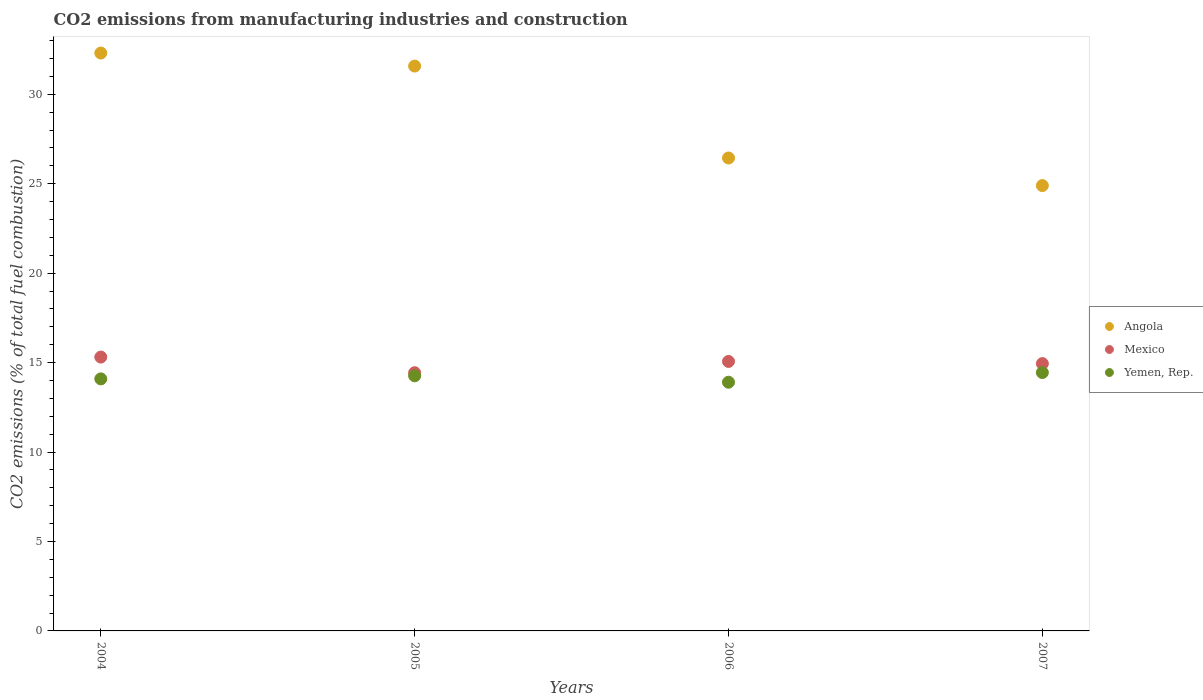Is the number of dotlines equal to the number of legend labels?
Keep it short and to the point. Yes. What is the amount of CO2 emitted in Yemen, Rep. in 2005?
Provide a short and direct response. 14.26. Across all years, what is the maximum amount of CO2 emitted in Yemen, Rep.?
Provide a succinct answer. 14.44. Across all years, what is the minimum amount of CO2 emitted in Yemen, Rep.?
Keep it short and to the point. 13.9. What is the total amount of CO2 emitted in Angola in the graph?
Your answer should be compact. 115.22. What is the difference between the amount of CO2 emitted in Angola in 2004 and that in 2007?
Provide a short and direct response. 7.41. What is the difference between the amount of CO2 emitted in Mexico in 2006 and the amount of CO2 emitted in Yemen, Rep. in 2004?
Keep it short and to the point. 0.97. What is the average amount of CO2 emitted in Mexico per year?
Your response must be concise. 14.94. In the year 2005, what is the difference between the amount of CO2 emitted in Angola and amount of CO2 emitted in Yemen, Rep.?
Give a very brief answer. 17.32. What is the ratio of the amount of CO2 emitted in Mexico in 2004 to that in 2006?
Provide a succinct answer. 1.02. Is the difference between the amount of CO2 emitted in Angola in 2005 and 2006 greater than the difference between the amount of CO2 emitted in Yemen, Rep. in 2005 and 2006?
Provide a short and direct response. Yes. What is the difference between the highest and the second highest amount of CO2 emitted in Mexico?
Provide a short and direct response. 0.24. What is the difference between the highest and the lowest amount of CO2 emitted in Angola?
Provide a succinct answer. 7.41. In how many years, is the amount of CO2 emitted in Mexico greater than the average amount of CO2 emitted in Mexico taken over all years?
Give a very brief answer. 3. Is the sum of the amount of CO2 emitted in Yemen, Rep. in 2006 and 2007 greater than the maximum amount of CO2 emitted in Mexico across all years?
Offer a terse response. Yes. Does the amount of CO2 emitted in Mexico monotonically increase over the years?
Your answer should be very brief. No. Is the amount of CO2 emitted in Mexico strictly less than the amount of CO2 emitted in Yemen, Rep. over the years?
Offer a very short reply. No. How many years are there in the graph?
Ensure brevity in your answer.  4. How are the legend labels stacked?
Give a very brief answer. Vertical. What is the title of the graph?
Provide a short and direct response. CO2 emissions from manufacturing industries and construction. What is the label or title of the Y-axis?
Your response must be concise. CO2 emissions (% of total fuel combustion). What is the CO2 emissions (% of total fuel combustion) of Angola in 2004?
Ensure brevity in your answer.  32.31. What is the CO2 emissions (% of total fuel combustion) in Mexico in 2004?
Your response must be concise. 15.31. What is the CO2 emissions (% of total fuel combustion) in Yemen, Rep. in 2004?
Your response must be concise. 14.09. What is the CO2 emissions (% of total fuel combustion) in Angola in 2005?
Keep it short and to the point. 31.58. What is the CO2 emissions (% of total fuel combustion) of Mexico in 2005?
Offer a terse response. 14.44. What is the CO2 emissions (% of total fuel combustion) of Yemen, Rep. in 2005?
Provide a short and direct response. 14.26. What is the CO2 emissions (% of total fuel combustion) in Angola in 2006?
Offer a very short reply. 26.44. What is the CO2 emissions (% of total fuel combustion) of Mexico in 2006?
Provide a short and direct response. 15.07. What is the CO2 emissions (% of total fuel combustion) in Yemen, Rep. in 2006?
Ensure brevity in your answer.  13.9. What is the CO2 emissions (% of total fuel combustion) in Angola in 2007?
Your answer should be very brief. 24.9. What is the CO2 emissions (% of total fuel combustion) of Mexico in 2007?
Ensure brevity in your answer.  14.95. What is the CO2 emissions (% of total fuel combustion) in Yemen, Rep. in 2007?
Your response must be concise. 14.44. Across all years, what is the maximum CO2 emissions (% of total fuel combustion) in Angola?
Offer a very short reply. 32.31. Across all years, what is the maximum CO2 emissions (% of total fuel combustion) in Mexico?
Keep it short and to the point. 15.31. Across all years, what is the maximum CO2 emissions (% of total fuel combustion) of Yemen, Rep.?
Ensure brevity in your answer.  14.44. Across all years, what is the minimum CO2 emissions (% of total fuel combustion) in Angola?
Keep it short and to the point. 24.9. Across all years, what is the minimum CO2 emissions (% of total fuel combustion) of Mexico?
Your response must be concise. 14.44. Across all years, what is the minimum CO2 emissions (% of total fuel combustion) of Yemen, Rep.?
Provide a succinct answer. 13.9. What is the total CO2 emissions (% of total fuel combustion) of Angola in the graph?
Your answer should be very brief. 115.22. What is the total CO2 emissions (% of total fuel combustion) in Mexico in the graph?
Your response must be concise. 59.76. What is the total CO2 emissions (% of total fuel combustion) of Yemen, Rep. in the graph?
Offer a terse response. 56.7. What is the difference between the CO2 emissions (% of total fuel combustion) in Angola in 2004 and that in 2005?
Give a very brief answer. 0.73. What is the difference between the CO2 emissions (% of total fuel combustion) of Mexico in 2004 and that in 2005?
Offer a terse response. 0.87. What is the difference between the CO2 emissions (% of total fuel combustion) of Yemen, Rep. in 2004 and that in 2005?
Your response must be concise. -0.17. What is the difference between the CO2 emissions (% of total fuel combustion) of Angola in 2004 and that in 2006?
Make the answer very short. 5.87. What is the difference between the CO2 emissions (% of total fuel combustion) of Mexico in 2004 and that in 2006?
Offer a very short reply. 0.24. What is the difference between the CO2 emissions (% of total fuel combustion) of Yemen, Rep. in 2004 and that in 2006?
Provide a succinct answer. 0.19. What is the difference between the CO2 emissions (% of total fuel combustion) in Angola in 2004 and that in 2007?
Provide a succinct answer. 7.41. What is the difference between the CO2 emissions (% of total fuel combustion) in Mexico in 2004 and that in 2007?
Make the answer very short. 0.36. What is the difference between the CO2 emissions (% of total fuel combustion) in Yemen, Rep. in 2004 and that in 2007?
Provide a succinct answer. -0.35. What is the difference between the CO2 emissions (% of total fuel combustion) in Angola in 2005 and that in 2006?
Your response must be concise. 5.14. What is the difference between the CO2 emissions (% of total fuel combustion) in Mexico in 2005 and that in 2006?
Offer a very short reply. -0.63. What is the difference between the CO2 emissions (% of total fuel combustion) in Yemen, Rep. in 2005 and that in 2006?
Make the answer very short. 0.36. What is the difference between the CO2 emissions (% of total fuel combustion) in Angola in 2005 and that in 2007?
Offer a very short reply. 6.68. What is the difference between the CO2 emissions (% of total fuel combustion) in Mexico in 2005 and that in 2007?
Give a very brief answer. -0.51. What is the difference between the CO2 emissions (% of total fuel combustion) of Yemen, Rep. in 2005 and that in 2007?
Offer a terse response. -0.18. What is the difference between the CO2 emissions (% of total fuel combustion) of Angola in 2006 and that in 2007?
Your response must be concise. 1.54. What is the difference between the CO2 emissions (% of total fuel combustion) in Mexico in 2006 and that in 2007?
Provide a succinct answer. 0.12. What is the difference between the CO2 emissions (% of total fuel combustion) in Yemen, Rep. in 2006 and that in 2007?
Provide a short and direct response. -0.54. What is the difference between the CO2 emissions (% of total fuel combustion) in Angola in 2004 and the CO2 emissions (% of total fuel combustion) in Mexico in 2005?
Your answer should be compact. 17.87. What is the difference between the CO2 emissions (% of total fuel combustion) of Angola in 2004 and the CO2 emissions (% of total fuel combustion) of Yemen, Rep. in 2005?
Provide a succinct answer. 18.05. What is the difference between the CO2 emissions (% of total fuel combustion) in Mexico in 2004 and the CO2 emissions (% of total fuel combustion) in Yemen, Rep. in 2005?
Offer a terse response. 1.05. What is the difference between the CO2 emissions (% of total fuel combustion) of Angola in 2004 and the CO2 emissions (% of total fuel combustion) of Mexico in 2006?
Provide a succinct answer. 17.24. What is the difference between the CO2 emissions (% of total fuel combustion) of Angola in 2004 and the CO2 emissions (% of total fuel combustion) of Yemen, Rep. in 2006?
Give a very brief answer. 18.4. What is the difference between the CO2 emissions (% of total fuel combustion) of Mexico in 2004 and the CO2 emissions (% of total fuel combustion) of Yemen, Rep. in 2006?
Provide a succinct answer. 1.41. What is the difference between the CO2 emissions (% of total fuel combustion) of Angola in 2004 and the CO2 emissions (% of total fuel combustion) of Mexico in 2007?
Make the answer very short. 17.36. What is the difference between the CO2 emissions (% of total fuel combustion) of Angola in 2004 and the CO2 emissions (% of total fuel combustion) of Yemen, Rep. in 2007?
Give a very brief answer. 17.86. What is the difference between the CO2 emissions (% of total fuel combustion) of Mexico in 2004 and the CO2 emissions (% of total fuel combustion) of Yemen, Rep. in 2007?
Your response must be concise. 0.87. What is the difference between the CO2 emissions (% of total fuel combustion) in Angola in 2005 and the CO2 emissions (% of total fuel combustion) in Mexico in 2006?
Provide a succinct answer. 16.51. What is the difference between the CO2 emissions (% of total fuel combustion) of Angola in 2005 and the CO2 emissions (% of total fuel combustion) of Yemen, Rep. in 2006?
Keep it short and to the point. 17.68. What is the difference between the CO2 emissions (% of total fuel combustion) of Mexico in 2005 and the CO2 emissions (% of total fuel combustion) of Yemen, Rep. in 2006?
Ensure brevity in your answer.  0.53. What is the difference between the CO2 emissions (% of total fuel combustion) of Angola in 2005 and the CO2 emissions (% of total fuel combustion) of Mexico in 2007?
Provide a succinct answer. 16.63. What is the difference between the CO2 emissions (% of total fuel combustion) in Angola in 2005 and the CO2 emissions (% of total fuel combustion) in Yemen, Rep. in 2007?
Provide a short and direct response. 17.13. What is the difference between the CO2 emissions (% of total fuel combustion) of Mexico in 2005 and the CO2 emissions (% of total fuel combustion) of Yemen, Rep. in 2007?
Make the answer very short. -0.01. What is the difference between the CO2 emissions (% of total fuel combustion) of Angola in 2006 and the CO2 emissions (% of total fuel combustion) of Mexico in 2007?
Ensure brevity in your answer.  11.49. What is the difference between the CO2 emissions (% of total fuel combustion) in Angola in 2006 and the CO2 emissions (% of total fuel combustion) in Yemen, Rep. in 2007?
Your response must be concise. 11.99. What is the difference between the CO2 emissions (% of total fuel combustion) of Mexico in 2006 and the CO2 emissions (% of total fuel combustion) of Yemen, Rep. in 2007?
Offer a very short reply. 0.62. What is the average CO2 emissions (% of total fuel combustion) in Angola per year?
Give a very brief answer. 28.81. What is the average CO2 emissions (% of total fuel combustion) in Mexico per year?
Give a very brief answer. 14.94. What is the average CO2 emissions (% of total fuel combustion) in Yemen, Rep. per year?
Provide a short and direct response. 14.18. In the year 2004, what is the difference between the CO2 emissions (% of total fuel combustion) in Angola and CO2 emissions (% of total fuel combustion) in Mexico?
Your answer should be very brief. 17. In the year 2004, what is the difference between the CO2 emissions (% of total fuel combustion) in Angola and CO2 emissions (% of total fuel combustion) in Yemen, Rep.?
Give a very brief answer. 18.22. In the year 2004, what is the difference between the CO2 emissions (% of total fuel combustion) of Mexico and CO2 emissions (% of total fuel combustion) of Yemen, Rep.?
Give a very brief answer. 1.22. In the year 2005, what is the difference between the CO2 emissions (% of total fuel combustion) in Angola and CO2 emissions (% of total fuel combustion) in Mexico?
Make the answer very short. 17.14. In the year 2005, what is the difference between the CO2 emissions (% of total fuel combustion) in Angola and CO2 emissions (% of total fuel combustion) in Yemen, Rep.?
Provide a short and direct response. 17.32. In the year 2005, what is the difference between the CO2 emissions (% of total fuel combustion) in Mexico and CO2 emissions (% of total fuel combustion) in Yemen, Rep.?
Your answer should be compact. 0.17. In the year 2006, what is the difference between the CO2 emissions (% of total fuel combustion) in Angola and CO2 emissions (% of total fuel combustion) in Mexico?
Provide a succinct answer. 11.37. In the year 2006, what is the difference between the CO2 emissions (% of total fuel combustion) of Angola and CO2 emissions (% of total fuel combustion) of Yemen, Rep.?
Make the answer very short. 12.54. In the year 2006, what is the difference between the CO2 emissions (% of total fuel combustion) in Mexico and CO2 emissions (% of total fuel combustion) in Yemen, Rep.?
Keep it short and to the point. 1.16. In the year 2007, what is the difference between the CO2 emissions (% of total fuel combustion) in Angola and CO2 emissions (% of total fuel combustion) in Mexico?
Your answer should be compact. 9.95. In the year 2007, what is the difference between the CO2 emissions (% of total fuel combustion) of Angola and CO2 emissions (% of total fuel combustion) of Yemen, Rep.?
Your answer should be compact. 10.45. In the year 2007, what is the difference between the CO2 emissions (% of total fuel combustion) in Mexico and CO2 emissions (% of total fuel combustion) in Yemen, Rep.?
Offer a very short reply. 0.5. What is the ratio of the CO2 emissions (% of total fuel combustion) in Angola in 2004 to that in 2005?
Your answer should be compact. 1.02. What is the ratio of the CO2 emissions (% of total fuel combustion) in Mexico in 2004 to that in 2005?
Provide a short and direct response. 1.06. What is the ratio of the CO2 emissions (% of total fuel combustion) of Yemen, Rep. in 2004 to that in 2005?
Provide a succinct answer. 0.99. What is the ratio of the CO2 emissions (% of total fuel combustion) in Angola in 2004 to that in 2006?
Provide a succinct answer. 1.22. What is the ratio of the CO2 emissions (% of total fuel combustion) in Mexico in 2004 to that in 2006?
Your answer should be very brief. 1.02. What is the ratio of the CO2 emissions (% of total fuel combustion) of Yemen, Rep. in 2004 to that in 2006?
Provide a short and direct response. 1.01. What is the ratio of the CO2 emissions (% of total fuel combustion) in Angola in 2004 to that in 2007?
Ensure brevity in your answer.  1.3. What is the ratio of the CO2 emissions (% of total fuel combustion) in Mexico in 2004 to that in 2007?
Ensure brevity in your answer.  1.02. What is the ratio of the CO2 emissions (% of total fuel combustion) in Yemen, Rep. in 2004 to that in 2007?
Your answer should be very brief. 0.98. What is the ratio of the CO2 emissions (% of total fuel combustion) in Angola in 2005 to that in 2006?
Make the answer very short. 1.19. What is the ratio of the CO2 emissions (% of total fuel combustion) in Mexico in 2005 to that in 2006?
Provide a short and direct response. 0.96. What is the ratio of the CO2 emissions (% of total fuel combustion) in Yemen, Rep. in 2005 to that in 2006?
Offer a very short reply. 1.03. What is the ratio of the CO2 emissions (% of total fuel combustion) of Angola in 2005 to that in 2007?
Give a very brief answer. 1.27. What is the ratio of the CO2 emissions (% of total fuel combustion) in Mexico in 2005 to that in 2007?
Give a very brief answer. 0.97. What is the ratio of the CO2 emissions (% of total fuel combustion) of Yemen, Rep. in 2005 to that in 2007?
Offer a very short reply. 0.99. What is the ratio of the CO2 emissions (% of total fuel combustion) of Angola in 2006 to that in 2007?
Provide a succinct answer. 1.06. What is the ratio of the CO2 emissions (% of total fuel combustion) in Mexico in 2006 to that in 2007?
Offer a terse response. 1.01. What is the ratio of the CO2 emissions (% of total fuel combustion) of Yemen, Rep. in 2006 to that in 2007?
Your answer should be very brief. 0.96. What is the difference between the highest and the second highest CO2 emissions (% of total fuel combustion) of Angola?
Offer a very short reply. 0.73. What is the difference between the highest and the second highest CO2 emissions (% of total fuel combustion) in Mexico?
Keep it short and to the point. 0.24. What is the difference between the highest and the second highest CO2 emissions (% of total fuel combustion) in Yemen, Rep.?
Provide a succinct answer. 0.18. What is the difference between the highest and the lowest CO2 emissions (% of total fuel combustion) in Angola?
Your answer should be compact. 7.41. What is the difference between the highest and the lowest CO2 emissions (% of total fuel combustion) in Mexico?
Keep it short and to the point. 0.87. What is the difference between the highest and the lowest CO2 emissions (% of total fuel combustion) of Yemen, Rep.?
Offer a terse response. 0.54. 